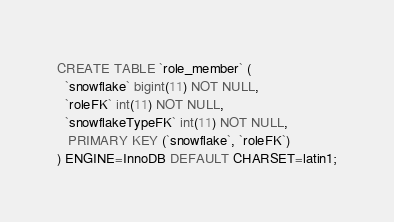Convert code to text. <code><loc_0><loc_0><loc_500><loc_500><_SQL_>CREATE TABLE `role_member` (
  `snowflake` bigint(11) NOT NULL,
  `roleFK` int(11) NOT NULL,
  `snowflakeTypeFK` int(11) NOT NULL,
   PRIMARY KEY (`snowflake`, `roleFK`)
) ENGINE=InnoDB DEFAULT CHARSET=latin1;
</code> 